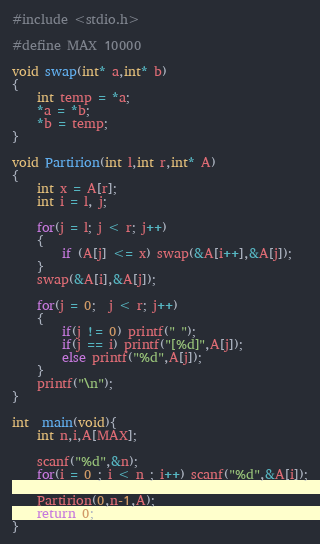<code> <loc_0><loc_0><loc_500><loc_500><_C_>#include <stdio.h>

#define MAX 10000

void swap(int* a,int* b)
{
    int temp = *a;
    *a = *b;
    *b = temp;
}

void Partirion(int l,int r,int* A)
{
    int x = A[r];
    int i = l, j;
    
    for(j = l; j < r; j++)
    {
        if (A[j] <= x) swap(&A[i++],&A[j]);
    }
    swap(&A[i],&A[j]);
    
    for(j = 0;  j < r; j++)
    {
        if(j != 0) printf(" ");
        if(j == i) printf("[%d]",A[j]);
        else printf("%d",A[j]);
    }
    printf("\n");
} 

int  main(void){
    int n,i,A[MAX];
    
    scanf("%d",&n);
    for(i = 0 ; i < n ; i++) scanf("%d",&A[i]);
    
    Partirion(0,n-1,A);
    return 0;
}

</code> 